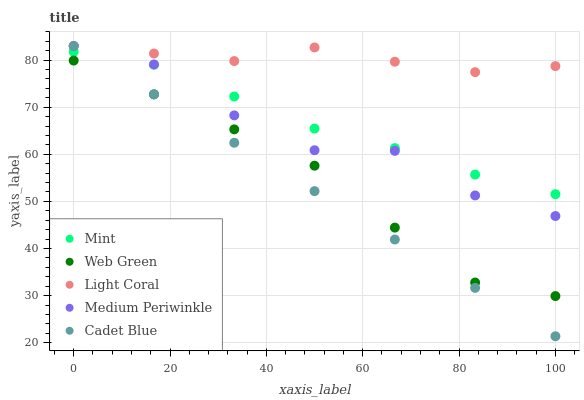Does Cadet Blue have the minimum area under the curve?
Answer yes or no. Yes. Does Light Coral have the maximum area under the curve?
Answer yes or no. Yes. Does Medium Periwinkle have the minimum area under the curve?
Answer yes or no. No. Does Medium Periwinkle have the maximum area under the curve?
Answer yes or no. No. Is Cadet Blue the smoothest?
Answer yes or no. Yes. Is Medium Periwinkle the roughest?
Answer yes or no. Yes. Is Medium Periwinkle the smoothest?
Answer yes or no. No. Is Cadet Blue the roughest?
Answer yes or no. No. Does Cadet Blue have the lowest value?
Answer yes or no. Yes. Does Medium Periwinkle have the lowest value?
Answer yes or no. No. Does Cadet Blue have the highest value?
Answer yes or no. Yes. Does Mint have the highest value?
Answer yes or no. No. Is Web Green less than Mint?
Answer yes or no. Yes. Is Light Coral greater than Mint?
Answer yes or no. Yes. Does Cadet Blue intersect Mint?
Answer yes or no. Yes. Is Cadet Blue less than Mint?
Answer yes or no. No. Is Cadet Blue greater than Mint?
Answer yes or no. No. Does Web Green intersect Mint?
Answer yes or no. No. 